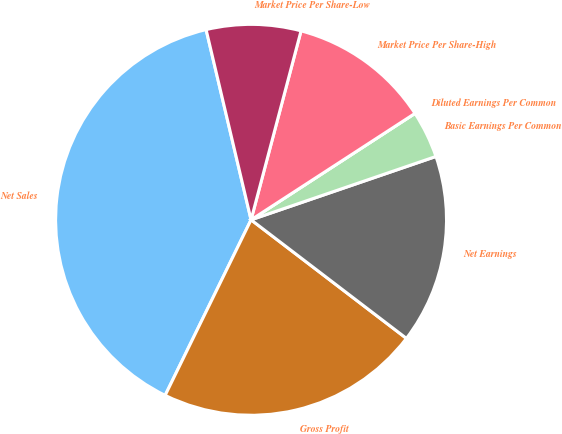Convert chart. <chart><loc_0><loc_0><loc_500><loc_500><pie_chart><fcel>Net Sales<fcel>Gross Profit<fcel>Net Earnings<fcel>Basic Earnings Per Common<fcel>Diluted Earnings Per Common<fcel>Market Price Per Share-High<fcel>Market Price Per Share-Low<nl><fcel>39.06%<fcel>21.87%<fcel>15.63%<fcel>3.91%<fcel>0.0%<fcel>11.72%<fcel>7.81%<nl></chart> 